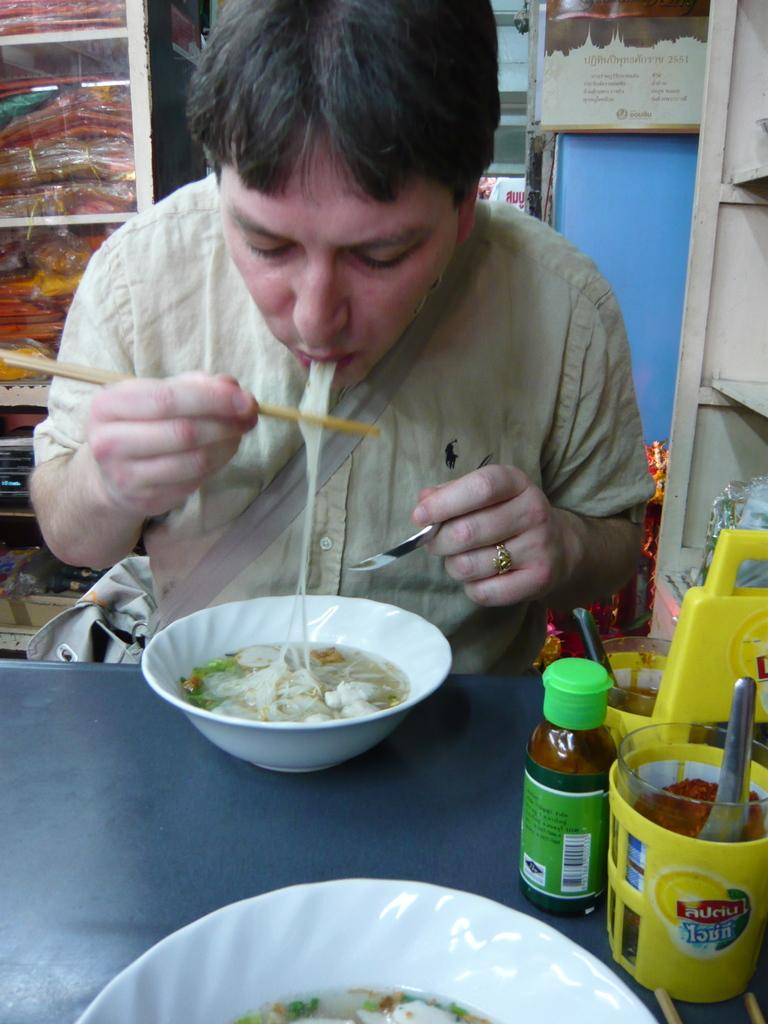<image>
Provide a brief description of the given image. A man eats noodles with chopsticks, the number 2551 can be seen 